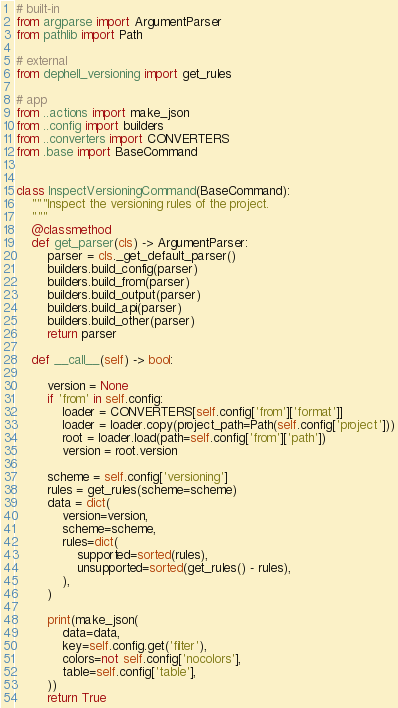<code> <loc_0><loc_0><loc_500><loc_500><_Python_># built-in
from argparse import ArgumentParser
from pathlib import Path

# external
from dephell_versioning import get_rules

# app
from ..actions import make_json
from ..config import builders
from ..converters import CONVERTERS
from .base import BaseCommand


class InspectVersioningCommand(BaseCommand):
    """Inspect the versioning rules of the project.
    """
    @classmethod
    def get_parser(cls) -> ArgumentParser:
        parser = cls._get_default_parser()
        builders.build_config(parser)
        builders.build_from(parser)
        builders.build_output(parser)
        builders.build_api(parser)
        builders.build_other(parser)
        return parser

    def __call__(self) -> bool:

        version = None
        if 'from' in self.config:
            loader = CONVERTERS[self.config['from']['format']]
            loader = loader.copy(project_path=Path(self.config['project']))
            root = loader.load(path=self.config['from']['path'])
            version = root.version

        scheme = self.config['versioning']
        rules = get_rules(scheme=scheme)
        data = dict(
            version=version,
            scheme=scheme,
            rules=dict(
                supported=sorted(rules),
                unsupported=sorted(get_rules() - rules),
            ),
        )

        print(make_json(
            data=data,
            key=self.config.get('filter'),
            colors=not self.config['nocolors'],
            table=self.config['table'],
        ))
        return True
</code> 